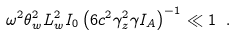<formula> <loc_0><loc_0><loc_500><loc_500>\omega ^ { 2 } \theta ^ { 2 } _ { w } L ^ { 2 } _ { w } I _ { 0 } \left ( 6 c ^ { 2 } \gamma ^ { 2 } _ { z } \gamma I _ { A } \right ) ^ { - 1 } \ll 1 \ .</formula> 